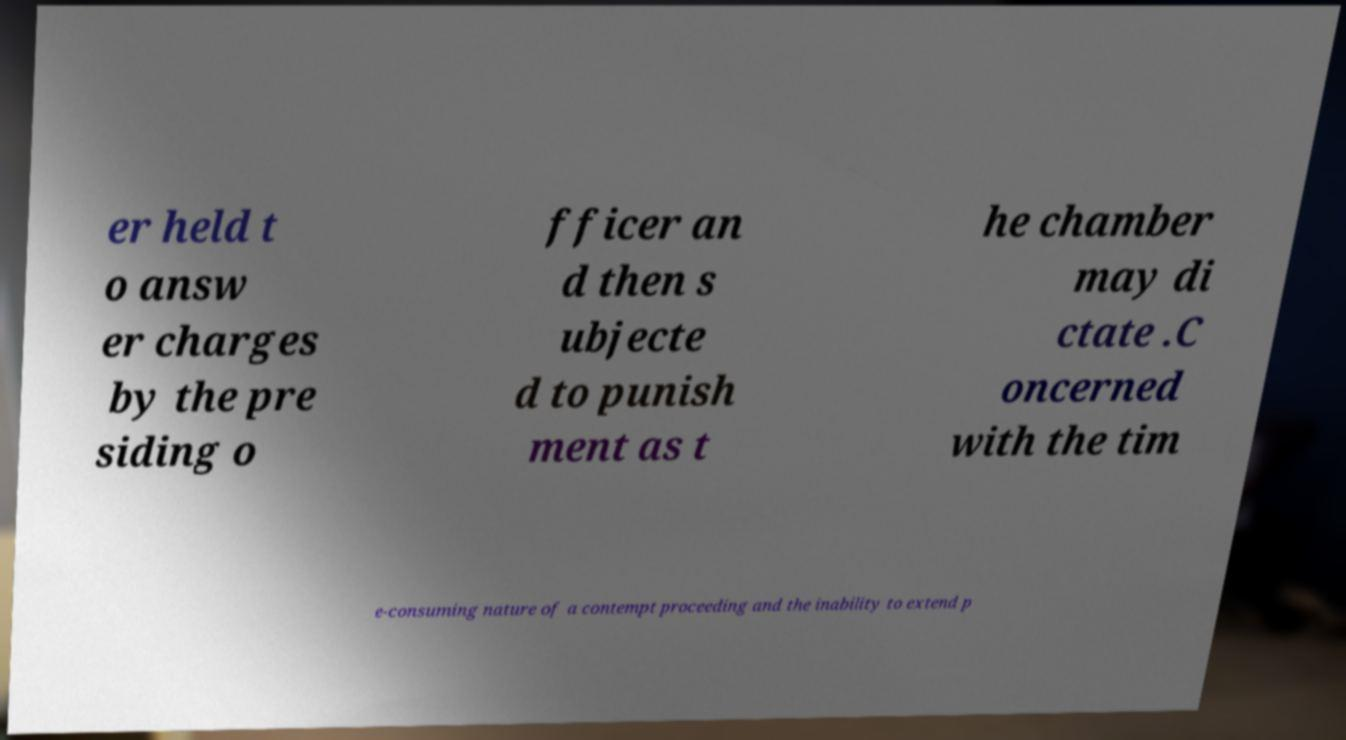For documentation purposes, I need the text within this image transcribed. Could you provide that? er held t o answ er charges by the pre siding o fficer an d then s ubjecte d to punish ment as t he chamber may di ctate .C oncerned with the tim e-consuming nature of a contempt proceeding and the inability to extend p 